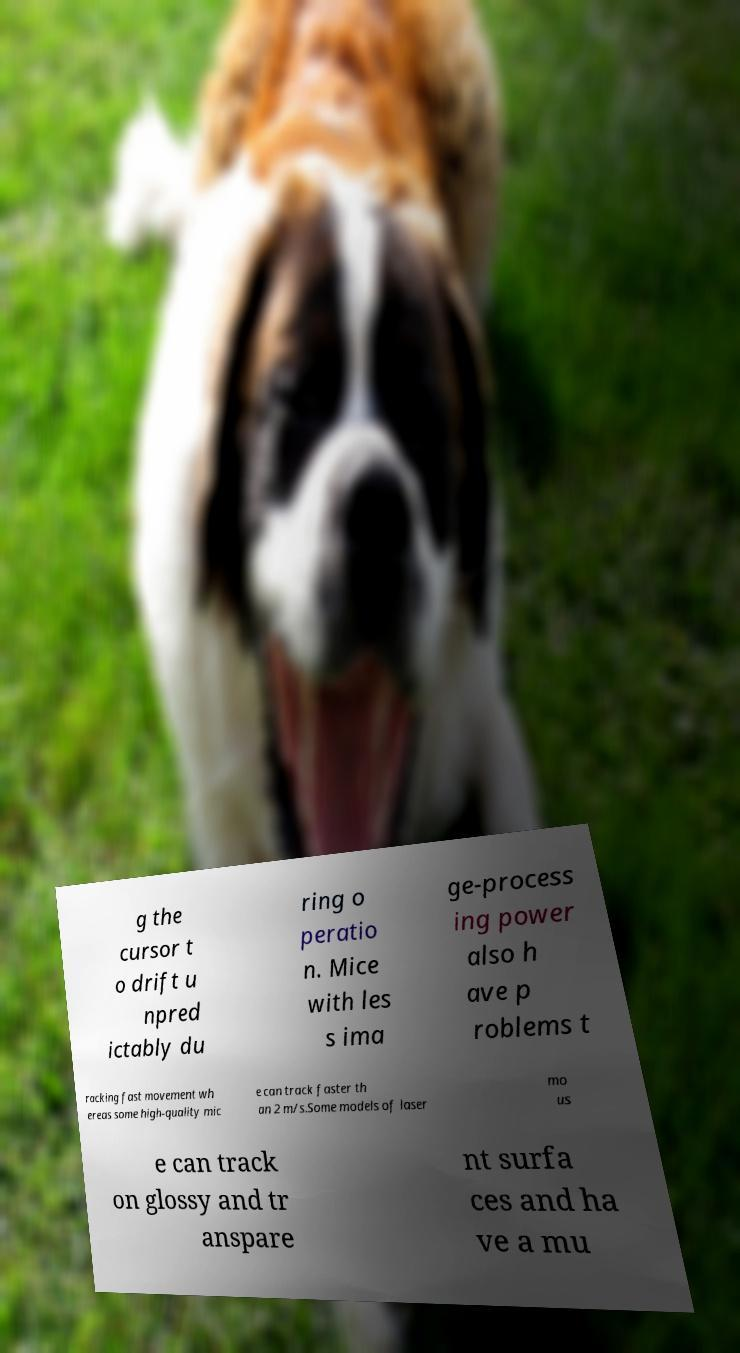Please read and relay the text visible in this image. What does it say? g the cursor t o drift u npred ictably du ring o peratio n. Mice with les s ima ge-process ing power also h ave p roblems t racking fast movement wh ereas some high-quality mic e can track faster th an 2 m/s.Some models of laser mo us e can track on glossy and tr anspare nt surfa ces and ha ve a mu 